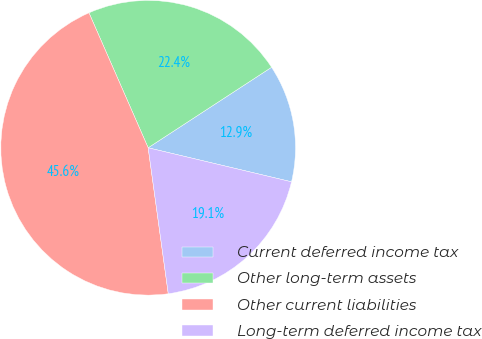Convert chart. <chart><loc_0><loc_0><loc_500><loc_500><pie_chart><fcel>Current deferred income tax<fcel>Other long-term assets<fcel>Other current liabilities<fcel>Long-term deferred income tax<nl><fcel>12.91%<fcel>22.38%<fcel>45.6%<fcel>19.11%<nl></chart> 